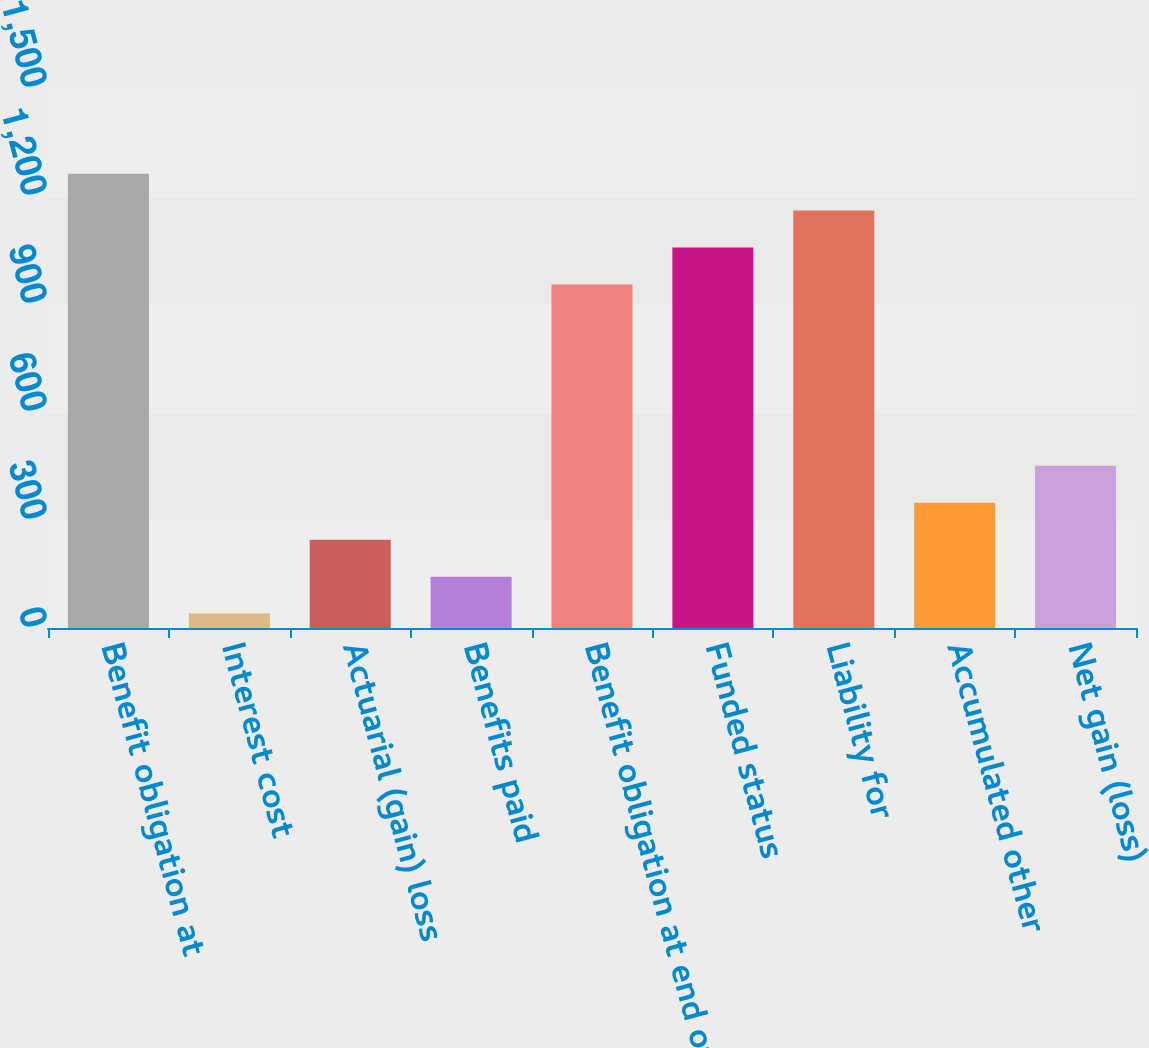Convert chart to OTSL. <chart><loc_0><loc_0><loc_500><loc_500><bar_chart><fcel>Benefit obligation at<fcel>Interest cost<fcel>Actuarial (gain) loss<fcel>Benefits paid<fcel>Benefit obligation at end of<fcel>Funded status<fcel>Liability for<fcel>Accumulated other<fcel>Net gain (loss)<nl><fcel>1262.1<fcel>40<fcel>245.4<fcel>142.7<fcel>954<fcel>1056.7<fcel>1159.4<fcel>348.1<fcel>450.8<nl></chart> 